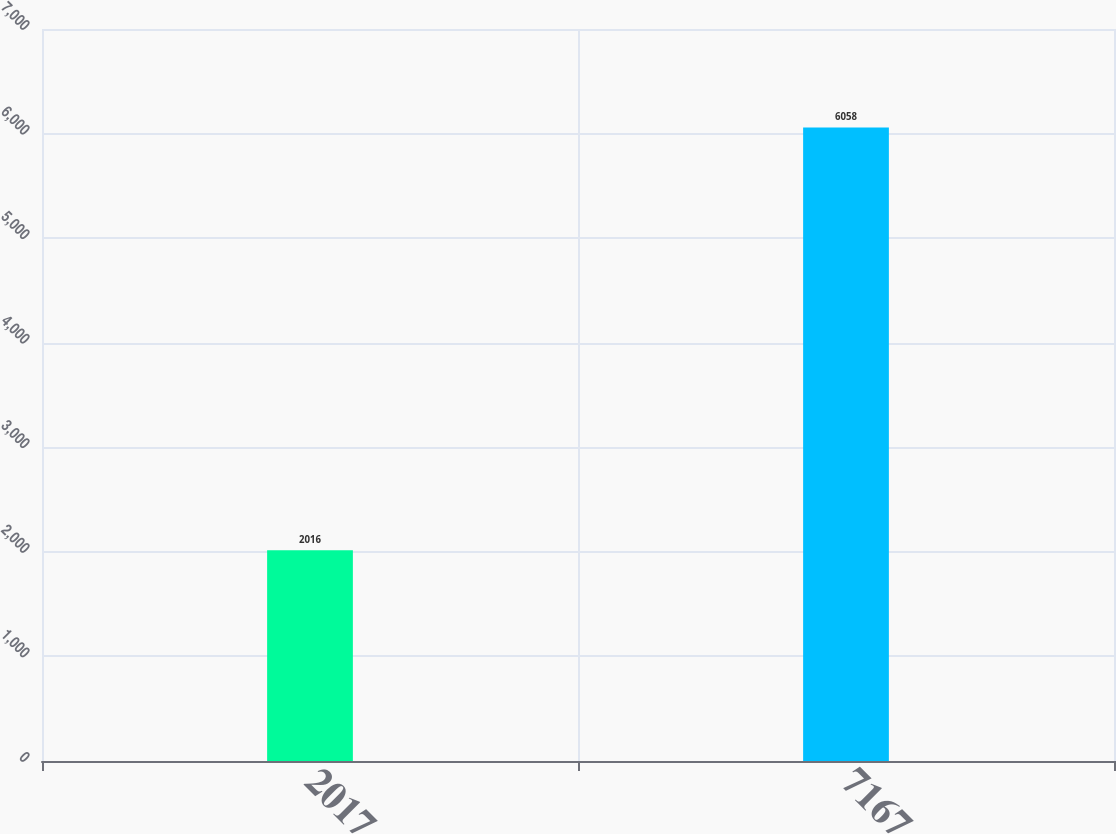Convert chart. <chart><loc_0><loc_0><loc_500><loc_500><bar_chart><fcel>2017<fcel>7167<nl><fcel>2016<fcel>6058<nl></chart> 